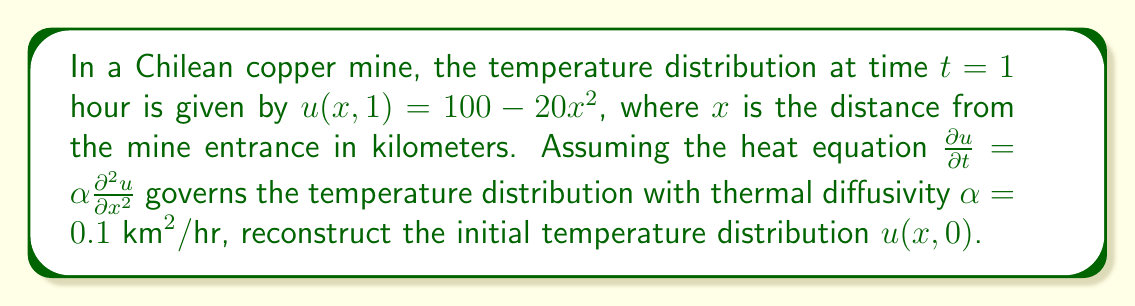Teach me how to tackle this problem. To solve this inverse problem, we'll use the following steps:

1) The general solution to the heat equation in 1D is given by:
   $$u(x,t) = \sum_{n=0}^{\infty} c_n e^{-\alpha n^2 \pi^2 t} \cos(n\pi x)$$

2) At $t=1$, we have $u(x,1) = 100 - 20x^2$. We need to express this in terms of cosine series:
   $$100 - 20x^2 = c_0 + c_1 \cos(\pi x) + c_2 \cos(2\pi x) + ...$$

3) Comparing coefficients:
   $c_0 = 100 - \frac{20}{3}$
   $c_2 = -\frac{20}{3}$
   All other coefficients are zero.

4) Now, we can write the solution at $t=1$ as:
   $$u(x,1) = (100 - \frac{20}{3}) + (-\frac{20}{3}) \cos(2\pi x)$$

5) To get the initial distribution, we need to "reverse" the time evolution:
   $$u(x,0) = (100 - \frac{20}{3}) + (-\frac{20}{3}) e^{0.1 \cdot 4\pi^2} \cos(2\pi x)$$

6) Simplifying:
   $$u(x,0) = \frac{280}{3} - \frac{20}{3} e^{3.9478} \cos(2\pi x)$$

This is the reconstructed initial temperature distribution.
Answer: $u(x,0) = \frac{280}{3} - \frac{20}{3} e^{3.9478} \cos(2\pi x)$ 